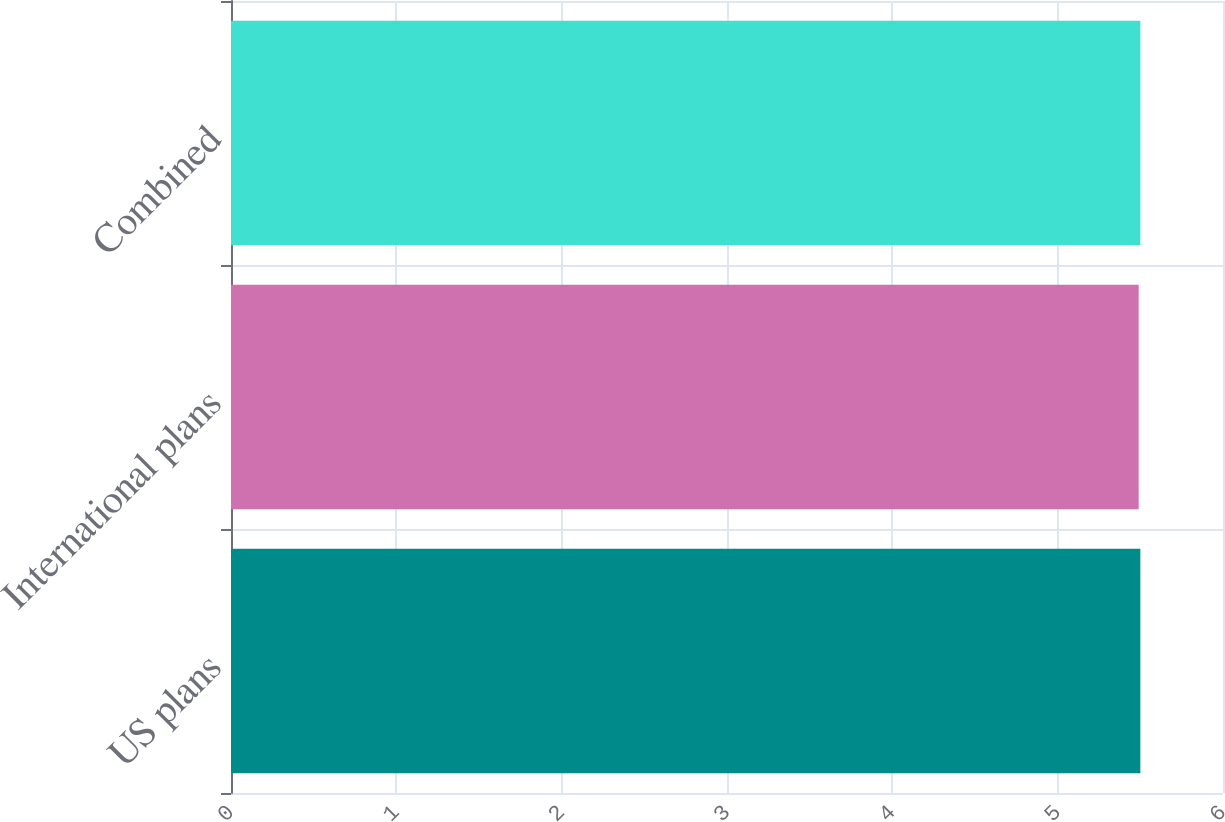Convert chart. <chart><loc_0><loc_0><loc_500><loc_500><bar_chart><fcel>US plans<fcel>International plans<fcel>Combined<nl><fcel>5.5<fcel>5.49<fcel>5.5<nl></chart> 